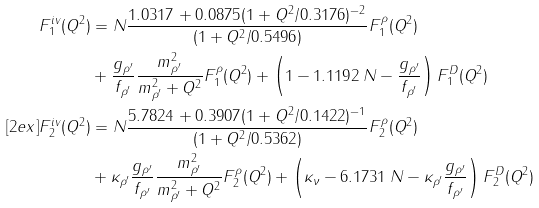Convert formula to latex. <formula><loc_0><loc_0><loc_500><loc_500>F ^ { \null { i v } } _ { 1 } ( Q ^ { 2 } ) & = N \frac { 1 . 0 3 1 7 + 0 . 0 8 7 5 ( 1 + Q ^ { 2 } / 0 . 3 1 7 6 ) ^ { - 2 } } { ( 1 + Q ^ { 2 } / 0 . 5 4 9 6 ) } F ^ { \rho } _ { 1 } ( Q ^ { 2 } ) \\ & + \frac { g _ { \rho ^ { \prime } } } { f _ { \rho ^ { \prime } } } \frac { m ^ { 2 } _ { \rho ^ { \prime } } } { m ^ { 2 } _ { \rho ^ { \prime } } + Q ^ { 2 } } F ^ { \rho } _ { 1 } ( Q ^ { 2 } ) + \left ( 1 - 1 . 1 1 9 2 \, N - \frac { g _ { \rho ^ { \prime } } } { f _ { \rho ^ { \prime } } } \right ) F ^ { D } _ { 1 } ( Q ^ { 2 } ) \\ [ 2 e x ] F ^ { \null { i v } } _ { 2 } ( Q ^ { 2 } ) & = N \frac { 5 . 7 8 2 4 + 0 . 3 9 0 7 ( 1 + Q ^ { 2 } / 0 . 1 4 2 2 ) ^ { - 1 } } { ( 1 + Q ^ { 2 } / 0 . 5 3 6 2 ) } F ^ { \rho } _ { 2 } ( Q ^ { 2 } ) \\ & + \kappa _ { \rho ^ { \prime } } \frac { g _ { \rho ^ { \prime } } } { f _ { \rho ^ { \prime } } } \frac { m ^ { 2 } _ { \rho ^ { \prime } } } { m ^ { 2 } _ { \rho ^ { \prime } } + Q ^ { 2 } } F ^ { \rho } _ { 2 } ( Q ^ { 2 } ) + \left ( \kappa _ { \nu } - 6 . 1 7 3 1 \, N - \kappa _ { \rho ^ { \prime } } \frac { g _ { \rho ^ { \prime } } } { f _ { \rho ^ { \prime } } } \right ) F ^ { D } _ { 2 } ( Q ^ { 2 } )</formula> 